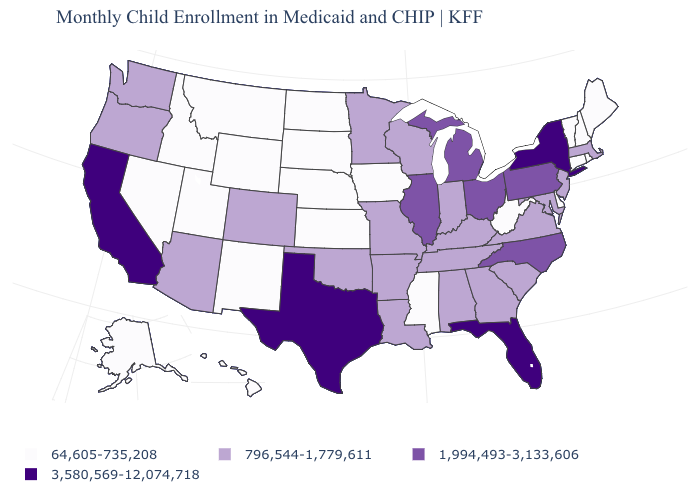Name the states that have a value in the range 796,544-1,779,611?
Answer briefly. Alabama, Arizona, Arkansas, Colorado, Georgia, Indiana, Kentucky, Louisiana, Maryland, Massachusetts, Minnesota, Missouri, New Jersey, Oklahoma, Oregon, South Carolina, Tennessee, Virginia, Washington, Wisconsin. How many symbols are there in the legend?
Quick response, please. 4. Does Oregon have the same value as Colorado?
Keep it brief. Yes. What is the value of Alaska?
Quick response, please. 64,605-735,208. Name the states that have a value in the range 1,994,493-3,133,606?
Give a very brief answer. Illinois, Michigan, North Carolina, Ohio, Pennsylvania. What is the value of Nevada?
Keep it brief. 64,605-735,208. Name the states that have a value in the range 796,544-1,779,611?
Keep it brief. Alabama, Arizona, Arkansas, Colorado, Georgia, Indiana, Kentucky, Louisiana, Maryland, Massachusetts, Minnesota, Missouri, New Jersey, Oklahoma, Oregon, South Carolina, Tennessee, Virginia, Washington, Wisconsin. What is the value of Ohio?
Keep it brief. 1,994,493-3,133,606. What is the lowest value in the USA?
Quick response, please. 64,605-735,208. Does the map have missing data?
Short answer required. No. Which states hav the highest value in the South?
Write a very short answer. Florida, Texas. Name the states that have a value in the range 796,544-1,779,611?
Short answer required. Alabama, Arizona, Arkansas, Colorado, Georgia, Indiana, Kentucky, Louisiana, Maryland, Massachusetts, Minnesota, Missouri, New Jersey, Oklahoma, Oregon, South Carolina, Tennessee, Virginia, Washington, Wisconsin. Name the states that have a value in the range 64,605-735,208?
Be succinct. Alaska, Connecticut, Delaware, Hawaii, Idaho, Iowa, Kansas, Maine, Mississippi, Montana, Nebraska, Nevada, New Hampshire, New Mexico, North Dakota, Rhode Island, South Dakota, Utah, Vermont, West Virginia, Wyoming. Among the states that border Colorado , does Oklahoma have the lowest value?
Answer briefly. No. 